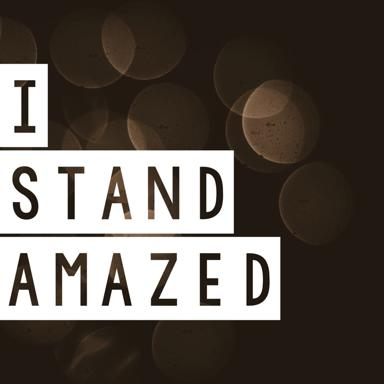What might be the meaning of the phrase "I Stand Amazed"? The phrase 'I Stand Amazed' conveys a deep feeling of astonishment or profound admiration, possibly triggered by an unexpected, remarkable experience or the beauty and complexity of something observed or realized. It's a personal expression likely used when ordinary words seem insufficient to describe the full extent of one's emotional response. 